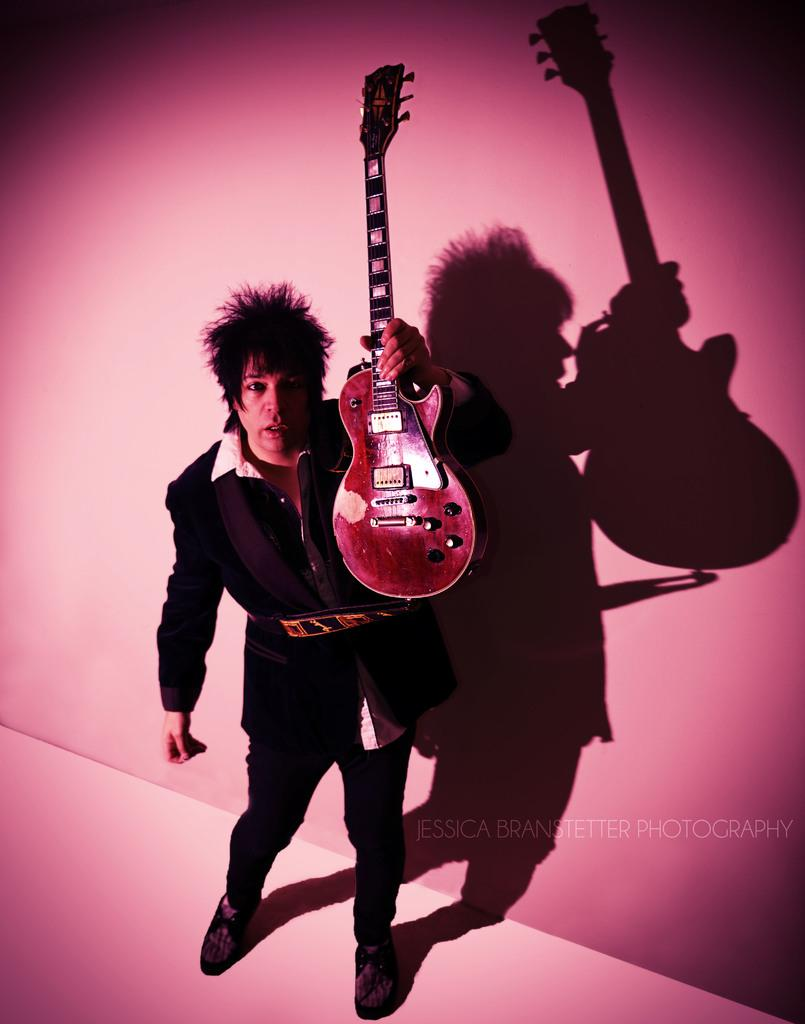What is the person in the image doing? The person is standing in the image and holding a musical instrument. What type of clothing is the person wearing on their upper body? The person is wearing a black blazer and a white shirt. What can be seen in the background of the image? The background of the image is in pink and white colors. How many bulbs are visible in the image? There are no bulbs present in the image. What is the amount of sticks used by the person in the image? The person in the image is holding a musical instrument, not sticks, so it is not possible to determine the amount of sticks used. 